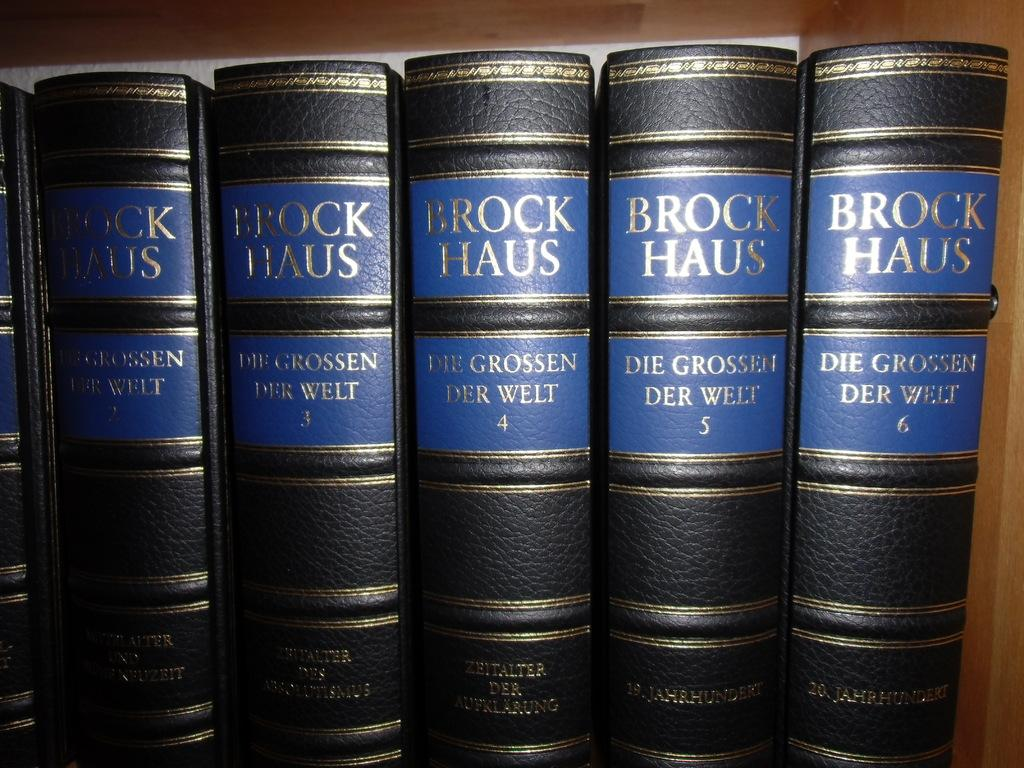<image>
Describe the image concisely. A set of books which have the words Brock Haus on them. 